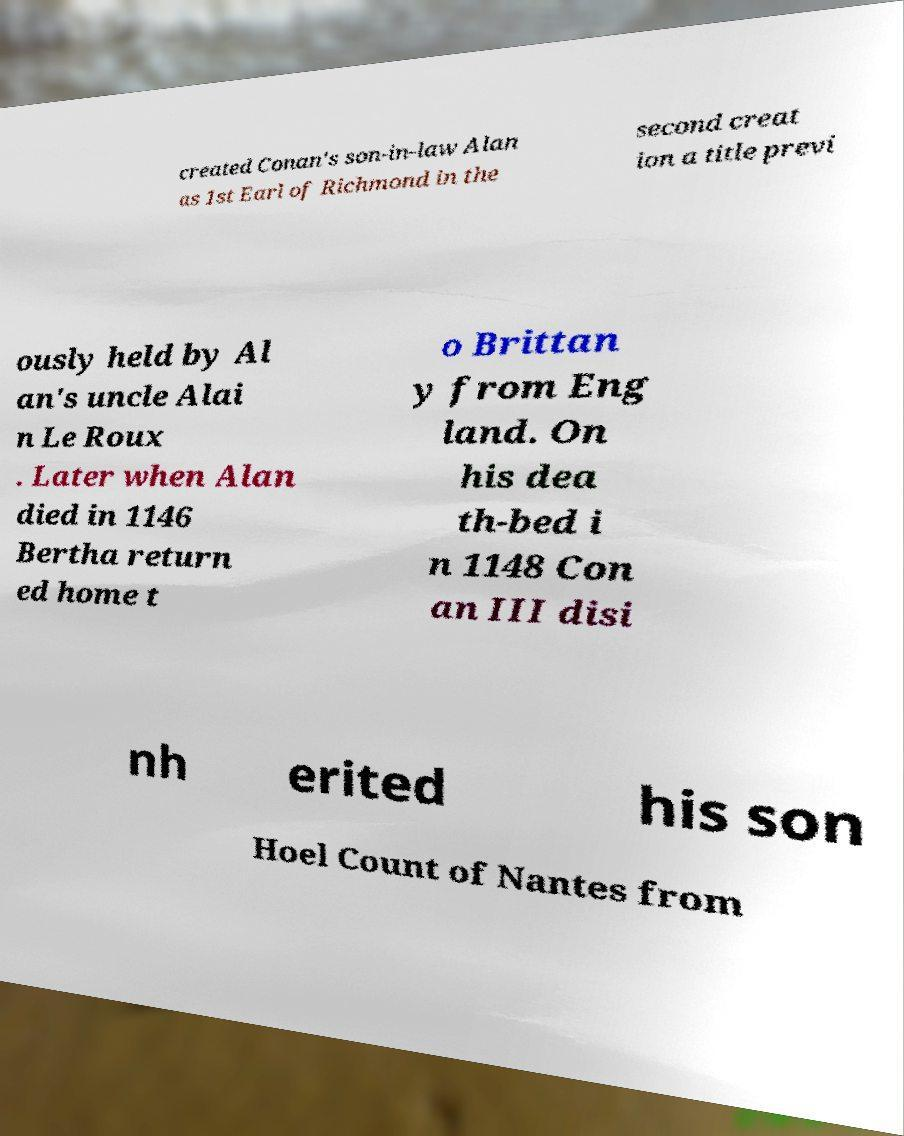Could you assist in decoding the text presented in this image and type it out clearly? created Conan's son-in-law Alan as 1st Earl of Richmond in the second creat ion a title previ ously held by Al an's uncle Alai n Le Roux . Later when Alan died in 1146 Bertha return ed home t o Brittan y from Eng land. On his dea th-bed i n 1148 Con an III disi nh erited his son Hoel Count of Nantes from 